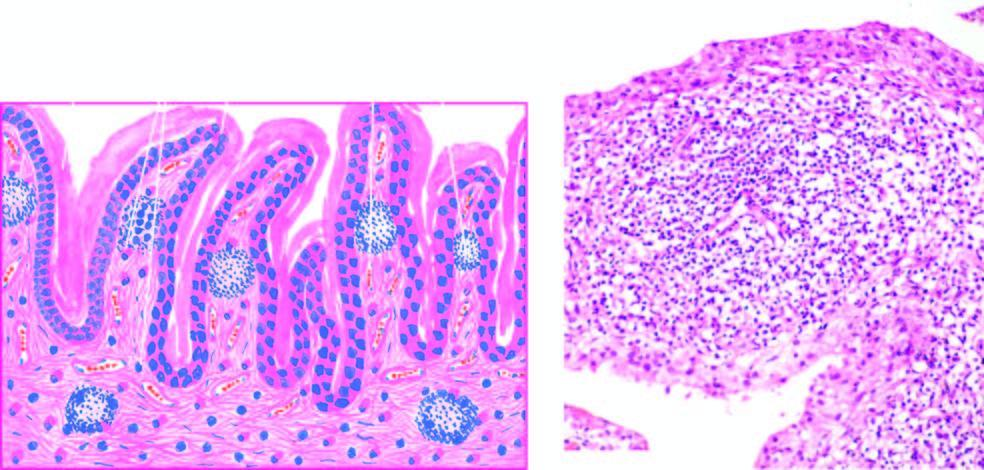what are the characteristic histologic features?
Answer the question using a single word or phrase. Villous hypertrophy of the synovium and marked mononuclear inflammatory cell 